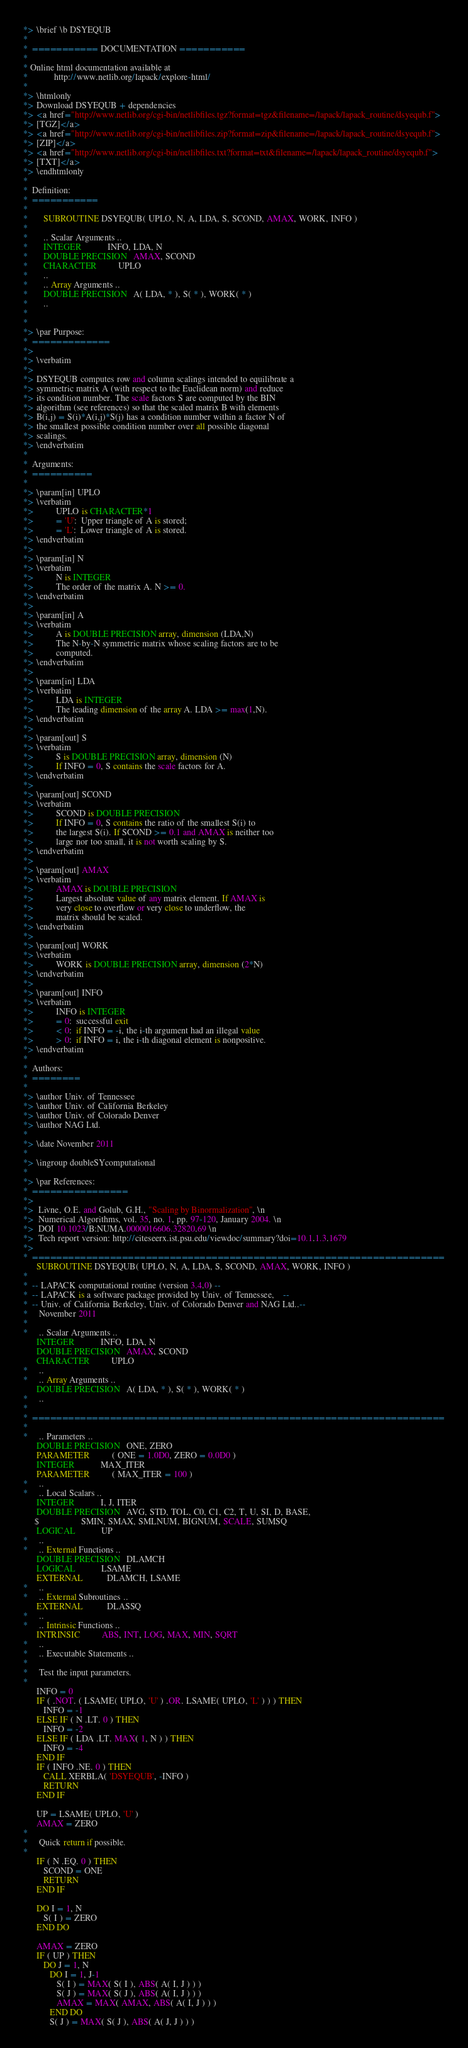Convert code to text. <code><loc_0><loc_0><loc_500><loc_500><_FORTRAN_>*> \brief \b DSYEQUB
*
*  =========== DOCUMENTATION ===========
*
* Online html documentation available at
*            http://www.netlib.org/lapack/explore-html/
*
*> \htmlonly
*> Download DSYEQUB + dependencies
*> <a href="http://www.netlib.org/cgi-bin/netlibfiles.tgz?format=tgz&filename=/lapack/lapack_routine/dsyequb.f">
*> [TGZ]</a>
*> <a href="http://www.netlib.org/cgi-bin/netlibfiles.zip?format=zip&filename=/lapack/lapack_routine/dsyequb.f">
*> [ZIP]</a>
*> <a href="http://www.netlib.org/cgi-bin/netlibfiles.txt?format=txt&filename=/lapack/lapack_routine/dsyequb.f">
*> [TXT]</a>
*> \endhtmlonly
*
*  Definition:
*  ===========
*
*       SUBROUTINE DSYEQUB( UPLO, N, A, LDA, S, SCOND, AMAX, WORK, INFO )
*
*       .. Scalar Arguments ..
*       INTEGER            INFO, LDA, N
*       DOUBLE PRECISION   AMAX, SCOND
*       CHARACTER          UPLO
*       ..
*       .. Array Arguments ..
*       DOUBLE PRECISION   A( LDA, * ), S( * ), WORK( * )
*       ..
*
*
*> \par Purpose:
*  =============
*>
*> \verbatim
*>
*> DSYEQUB computes row and column scalings intended to equilibrate a
*> symmetric matrix A (with respect to the Euclidean norm) and reduce
*> its condition number. The scale factors S are computed by the BIN
*> algorithm (see references) so that the scaled matrix B with elements
*> B(i,j) = S(i)*A(i,j)*S(j) has a condition number within a factor N of
*> the smallest possible condition number over all possible diagonal
*> scalings.
*> \endverbatim
*
*  Arguments:
*  ==========
*
*> \param[in] UPLO
*> \verbatim
*>          UPLO is CHARACTER*1
*>          = 'U':  Upper triangle of A is stored;
*>          = 'L':  Lower triangle of A is stored.
*> \endverbatim
*>
*> \param[in] N
*> \verbatim
*>          N is INTEGER
*>          The order of the matrix A. N >= 0.
*> \endverbatim
*>
*> \param[in] A
*> \verbatim
*>          A is DOUBLE PRECISION array, dimension (LDA,N)
*>          The N-by-N symmetric matrix whose scaling factors are to be
*>          computed.
*> \endverbatim
*>
*> \param[in] LDA
*> \verbatim
*>          LDA is INTEGER
*>          The leading dimension of the array A. LDA >= max(1,N).
*> \endverbatim
*>
*> \param[out] S
*> \verbatim
*>          S is DOUBLE PRECISION array, dimension (N)
*>          If INFO = 0, S contains the scale factors for A.
*> \endverbatim
*>
*> \param[out] SCOND
*> \verbatim
*>          SCOND is DOUBLE PRECISION
*>          If INFO = 0, S contains the ratio of the smallest S(i) to
*>          the largest S(i). If SCOND >= 0.1 and AMAX is neither too
*>          large nor too small, it is not worth scaling by S.
*> \endverbatim
*>
*> \param[out] AMAX
*> \verbatim
*>          AMAX is DOUBLE PRECISION
*>          Largest absolute value of any matrix element. If AMAX is
*>          very close to overflow or very close to underflow, the
*>          matrix should be scaled.
*> \endverbatim
*>
*> \param[out] WORK
*> \verbatim
*>          WORK is DOUBLE PRECISION array, dimension (2*N)
*> \endverbatim
*>
*> \param[out] INFO
*> \verbatim
*>          INFO is INTEGER
*>          = 0:  successful exit
*>          < 0:  if INFO = -i, the i-th argument had an illegal value
*>          > 0:  if INFO = i, the i-th diagonal element is nonpositive.
*> \endverbatim
*
*  Authors:
*  ========
*
*> \author Univ. of Tennessee
*> \author Univ. of California Berkeley
*> \author Univ. of Colorado Denver
*> \author NAG Ltd.
*
*> \date November 2011
*
*> \ingroup doubleSYcomputational
*
*> \par References:
*  ================
*>
*>  Livne, O.E. and Golub, G.H., "Scaling by Binormalization", \n
*>  Numerical Algorithms, vol. 35, no. 1, pp. 97-120, January 2004. \n
*>  DOI 10.1023/B:NUMA.0000016606.32820.69 \n
*>  Tech report version: http://citeseerx.ist.psu.edu/viewdoc/summary?doi=10.1.1.3.1679
*>
*  =====================================================================
      SUBROUTINE DSYEQUB( UPLO, N, A, LDA, S, SCOND, AMAX, WORK, INFO )
*
*  -- LAPACK computational routine (version 3.4.0) --
*  -- LAPACK is a software package provided by Univ. of Tennessee,    --
*  -- Univ. of California Berkeley, Univ. of Colorado Denver and NAG Ltd..--
*     November 2011
*
*     .. Scalar Arguments ..
      INTEGER            INFO, LDA, N
      DOUBLE PRECISION   AMAX, SCOND
      CHARACTER          UPLO
*     ..
*     .. Array Arguments ..
      DOUBLE PRECISION   A( LDA, * ), S( * ), WORK( * )
*     ..
*
*  =====================================================================
*
*     .. Parameters ..
      DOUBLE PRECISION   ONE, ZERO
      PARAMETER          ( ONE = 1.0D0, ZERO = 0.0D0 )
      INTEGER            MAX_ITER
      PARAMETER          ( MAX_ITER = 100 )
*     ..
*     .. Local Scalars ..
      INTEGER            I, J, ITER
      DOUBLE PRECISION   AVG, STD, TOL, C0, C1, C2, T, U, SI, D, BASE,
     $                   SMIN, SMAX, SMLNUM, BIGNUM, SCALE, SUMSQ
      LOGICAL            UP
*     ..
*     .. External Functions ..
      DOUBLE PRECISION   DLAMCH
      LOGICAL            LSAME
      EXTERNAL           DLAMCH, LSAME
*     ..
*     .. External Subroutines ..
      EXTERNAL           DLASSQ
*     ..
*     .. Intrinsic Functions ..
      INTRINSIC          ABS, INT, LOG, MAX, MIN, SQRT
*     ..
*     .. Executable Statements ..
*
*     Test the input parameters.
*
      INFO = 0
      IF ( .NOT. ( LSAME( UPLO, 'U' ) .OR. LSAME( UPLO, 'L' ) ) ) THEN
         INFO = -1
      ELSE IF ( N .LT. 0 ) THEN
         INFO = -2
      ELSE IF ( LDA .LT. MAX( 1, N ) ) THEN
         INFO = -4
      END IF
      IF ( INFO .NE. 0 ) THEN
         CALL XERBLA( 'DSYEQUB', -INFO )
         RETURN
      END IF

      UP = LSAME( UPLO, 'U' )
      AMAX = ZERO
*
*     Quick return if possible.
*
      IF ( N .EQ. 0 ) THEN
         SCOND = ONE
         RETURN
      END IF

      DO I = 1, N
         S( I ) = ZERO
      END DO

      AMAX = ZERO
      IF ( UP ) THEN
         DO J = 1, N
            DO I = 1, J-1
               S( I ) = MAX( S( I ), ABS( A( I, J ) ) )
               S( J ) = MAX( S( J ), ABS( A( I, J ) ) )
               AMAX = MAX( AMAX, ABS( A( I, J ) ) )
            END DO
            S( J ) = MAX( S( J ), ABS( A( J, J ) ) )</code> 